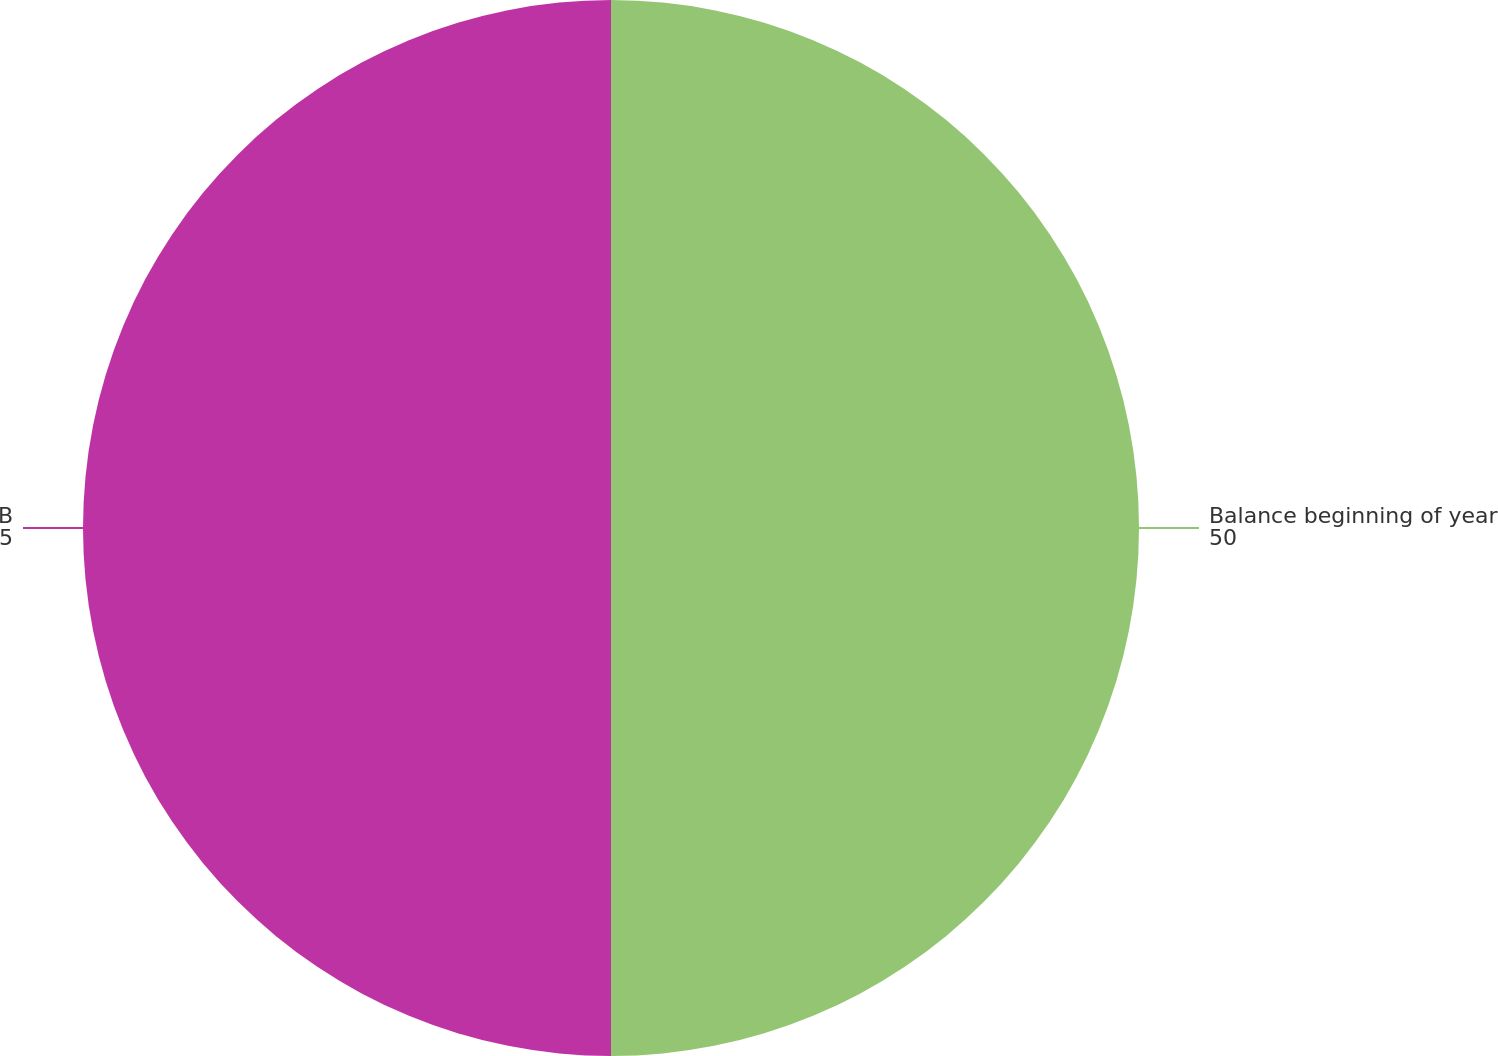Convert chart to OTSL. <chart><loc_0><loc_0><loc_500><loc_500><pie_chart><fcel>Balance beginning of year<fcel>Balance end of year<nl><fcel>50.0%<fcel>50.0%<nl></chart> 